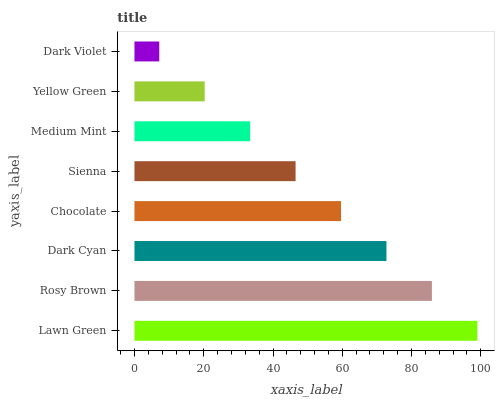Is Dark Violet the minimum?
Answer yes or no. Yes. Is Lawn Green the maximum?
Answer yes or no. Yes. Is Rosy Brown the minimum?
Answer yes or no. No. Is Rosy Brown the maximum?
Answer yes or no. No. Is Lawn Green greater than Rosy Brown?
Answer yes or no. Yes. Is Rosy Brown less than Lawn Green?
Answer yes or no. Yes. Is Rosy Brown greater than Lawn Green?
Answer yes or no. No. Is Lawn Green less than Rosy Brown?
Answer yes or no. No. Is Chocolate the high median?
Answer yes or no. Yes. Is Sienna the low median?
Answer yes or no. Yes. Is Dark Violet the high median?
Answer yes or no. No. Is Dark Violet the low median?
Answer yes or no. No. 